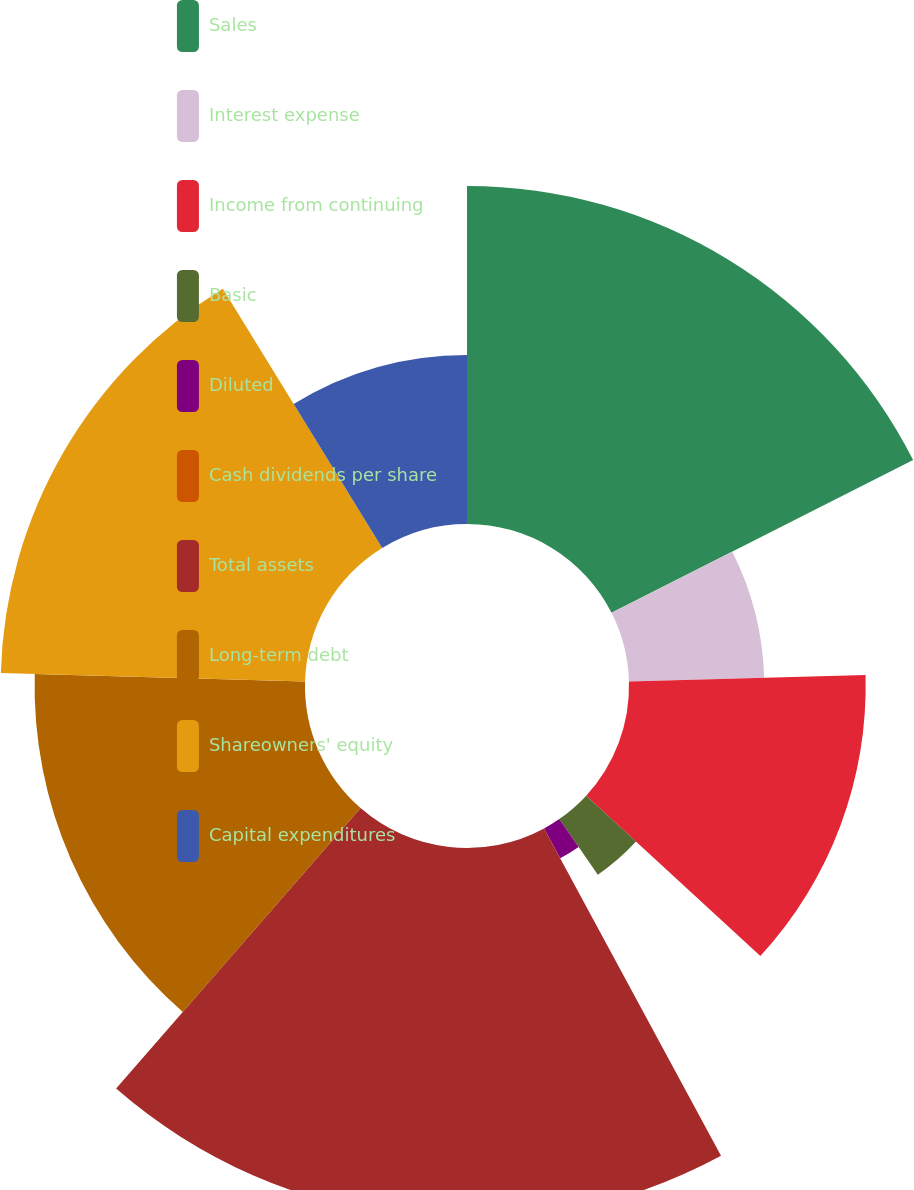<chart> <loc_0><loc_0><loc_500><loc_500><pie_chart><fcel>Sales<fcel>Interest expense<fcel>Income from continuing<fcel>Basic<fcel>Diluted<fcel>Cash dividends per share<fcel>Total assets<fcel>Long-term debt<fcel>Shareowners' equity<fcel>Capital expenditures<nl><fcel>17.54%<fcel>7.02%<fcel>12.28%<fcel>3.51%<fcel>1.76%<fcel>0.0%<fcel>19.3%<fcel>14.03%<fcel>15.79%<fcel>8.77%<nl></chart> 